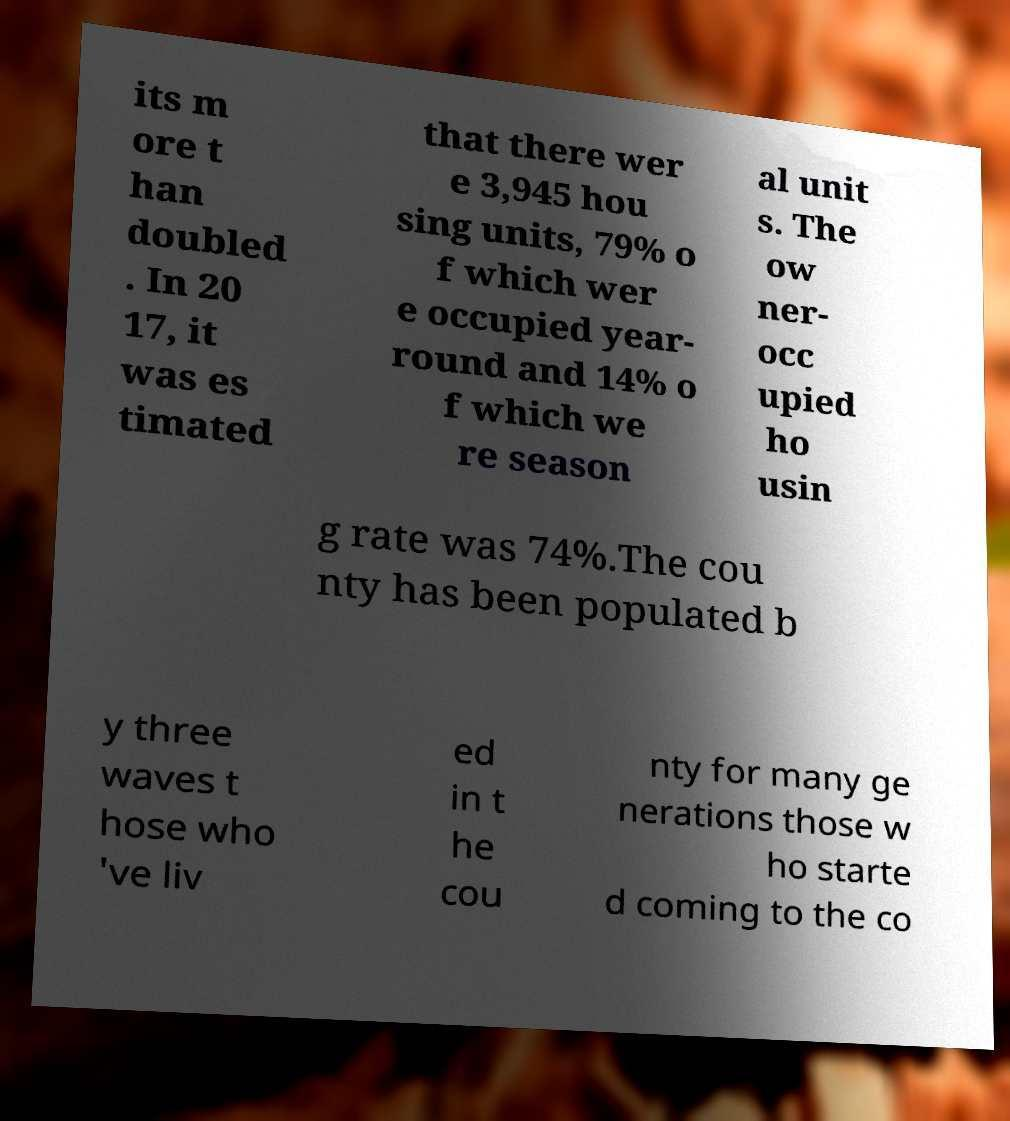Could you assist in decoding the text presented in this image and type it out clearly? its m ore t han doubled . In 20 17, it was es timated that there wer e 3,945 hou sing units, 79% o f which wer e occupied year- round and 14% o f which we re season al unit s. The ow ner- occ upied ho usin g rate was 74%.The cou nty has been populated b y three waves t hose who 've liv ed in t he cou nty for many ge nerations those w ho starte d coming to the co 